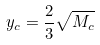Convert formula to latex. <formula><loc_0><loc_0><loc_500><loc_500>y _ { c } = \frac { 2 } { 3 } \sqrt { M _ { c } }</formula> 